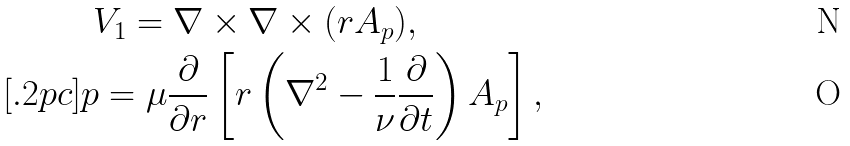Convert formula to latex. <formula><loc_0><loc_0><loc_500><loc_500>& \ V _ { 1 } = \nabla \times \nabla \times ( { r } A _ { p } ) , \\ [ . 2 p c ] & p = \mu \frac { \partial } { \partial r } \left [ r \left ( \nabla ^ { 2 } - \frac { 1 } { \nu } \frac { \partial } { \partial t } \right ) A _ { p } \right ] ,</formula> 